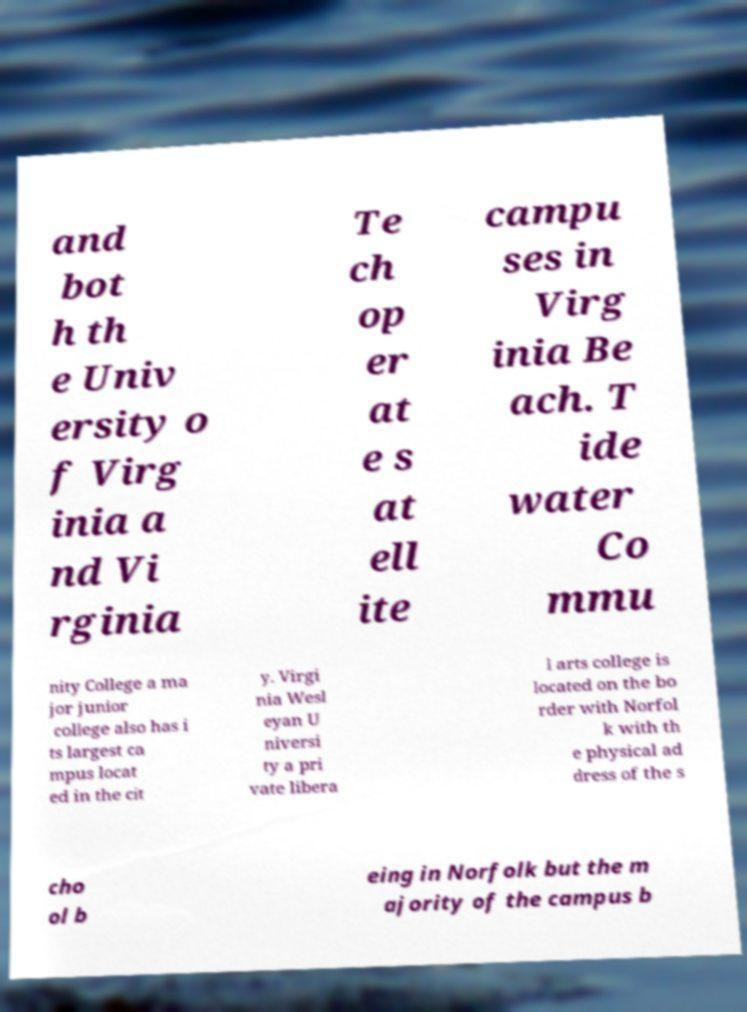Can you accurately transcribe the text from the provided image for me? and bot h th e Univ ersity o f Virg inia a nd Vi rginia Te ch op er at e s at ell ite campu ses in Virg inia Be ach. T ide water Co mmu nity College a ma jor junior college also has i ts largest ca mpus locat ed in the cit y. Virgi nia Wesl eyan U niversi ty a pri vate libera l arts college is located on the bo rder with Norfol k with th e physical ad dress of the s cho ol b eing in Norfolk but the m ajority of the campus b 